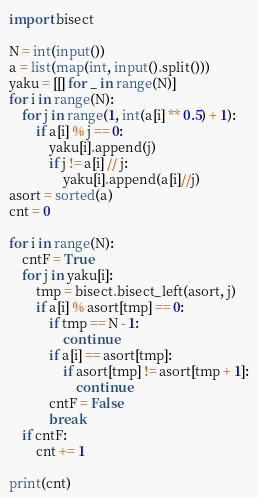<code> <loc_0><loc_0><loc_500><loc_500><_Python_>import bisect

N = int(input())
a = list(map(int, input().split()))
yaku = [[] for _ in range(N)]
for i in range(N):
    for j in range(1, int(a[i] ** 0.5) + 1):
        if a[i] % j == 0:
            yaku[i].append(j)
            if j != a[i] // j:
                yaku[i].append(a[i]//j)
asort = sorted(a)
cnt = 0

for i in range(N):
    cntF = True
    for j in yaku[i]:
        tmp = bisect.bisect_left(asort, j)
        if a[i] % asort[tmp] == 0:
            if tmp == N - 1:
                continue
            if a[i] == asort[tmp]:
                if asort[tmp] != asort[tmp + 1]:
                    continue
            cntF = False
            break
    if cntF:
        cnt += 1

print(cnt)</code> 